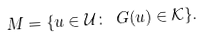Convert formula to latex. <formula><loc_0><loc_0><loc_500><loc_500>M = \{ u \in \mathcal { U } \colon \ G ( u ) \in \mathcal { K } \} .</formula> 